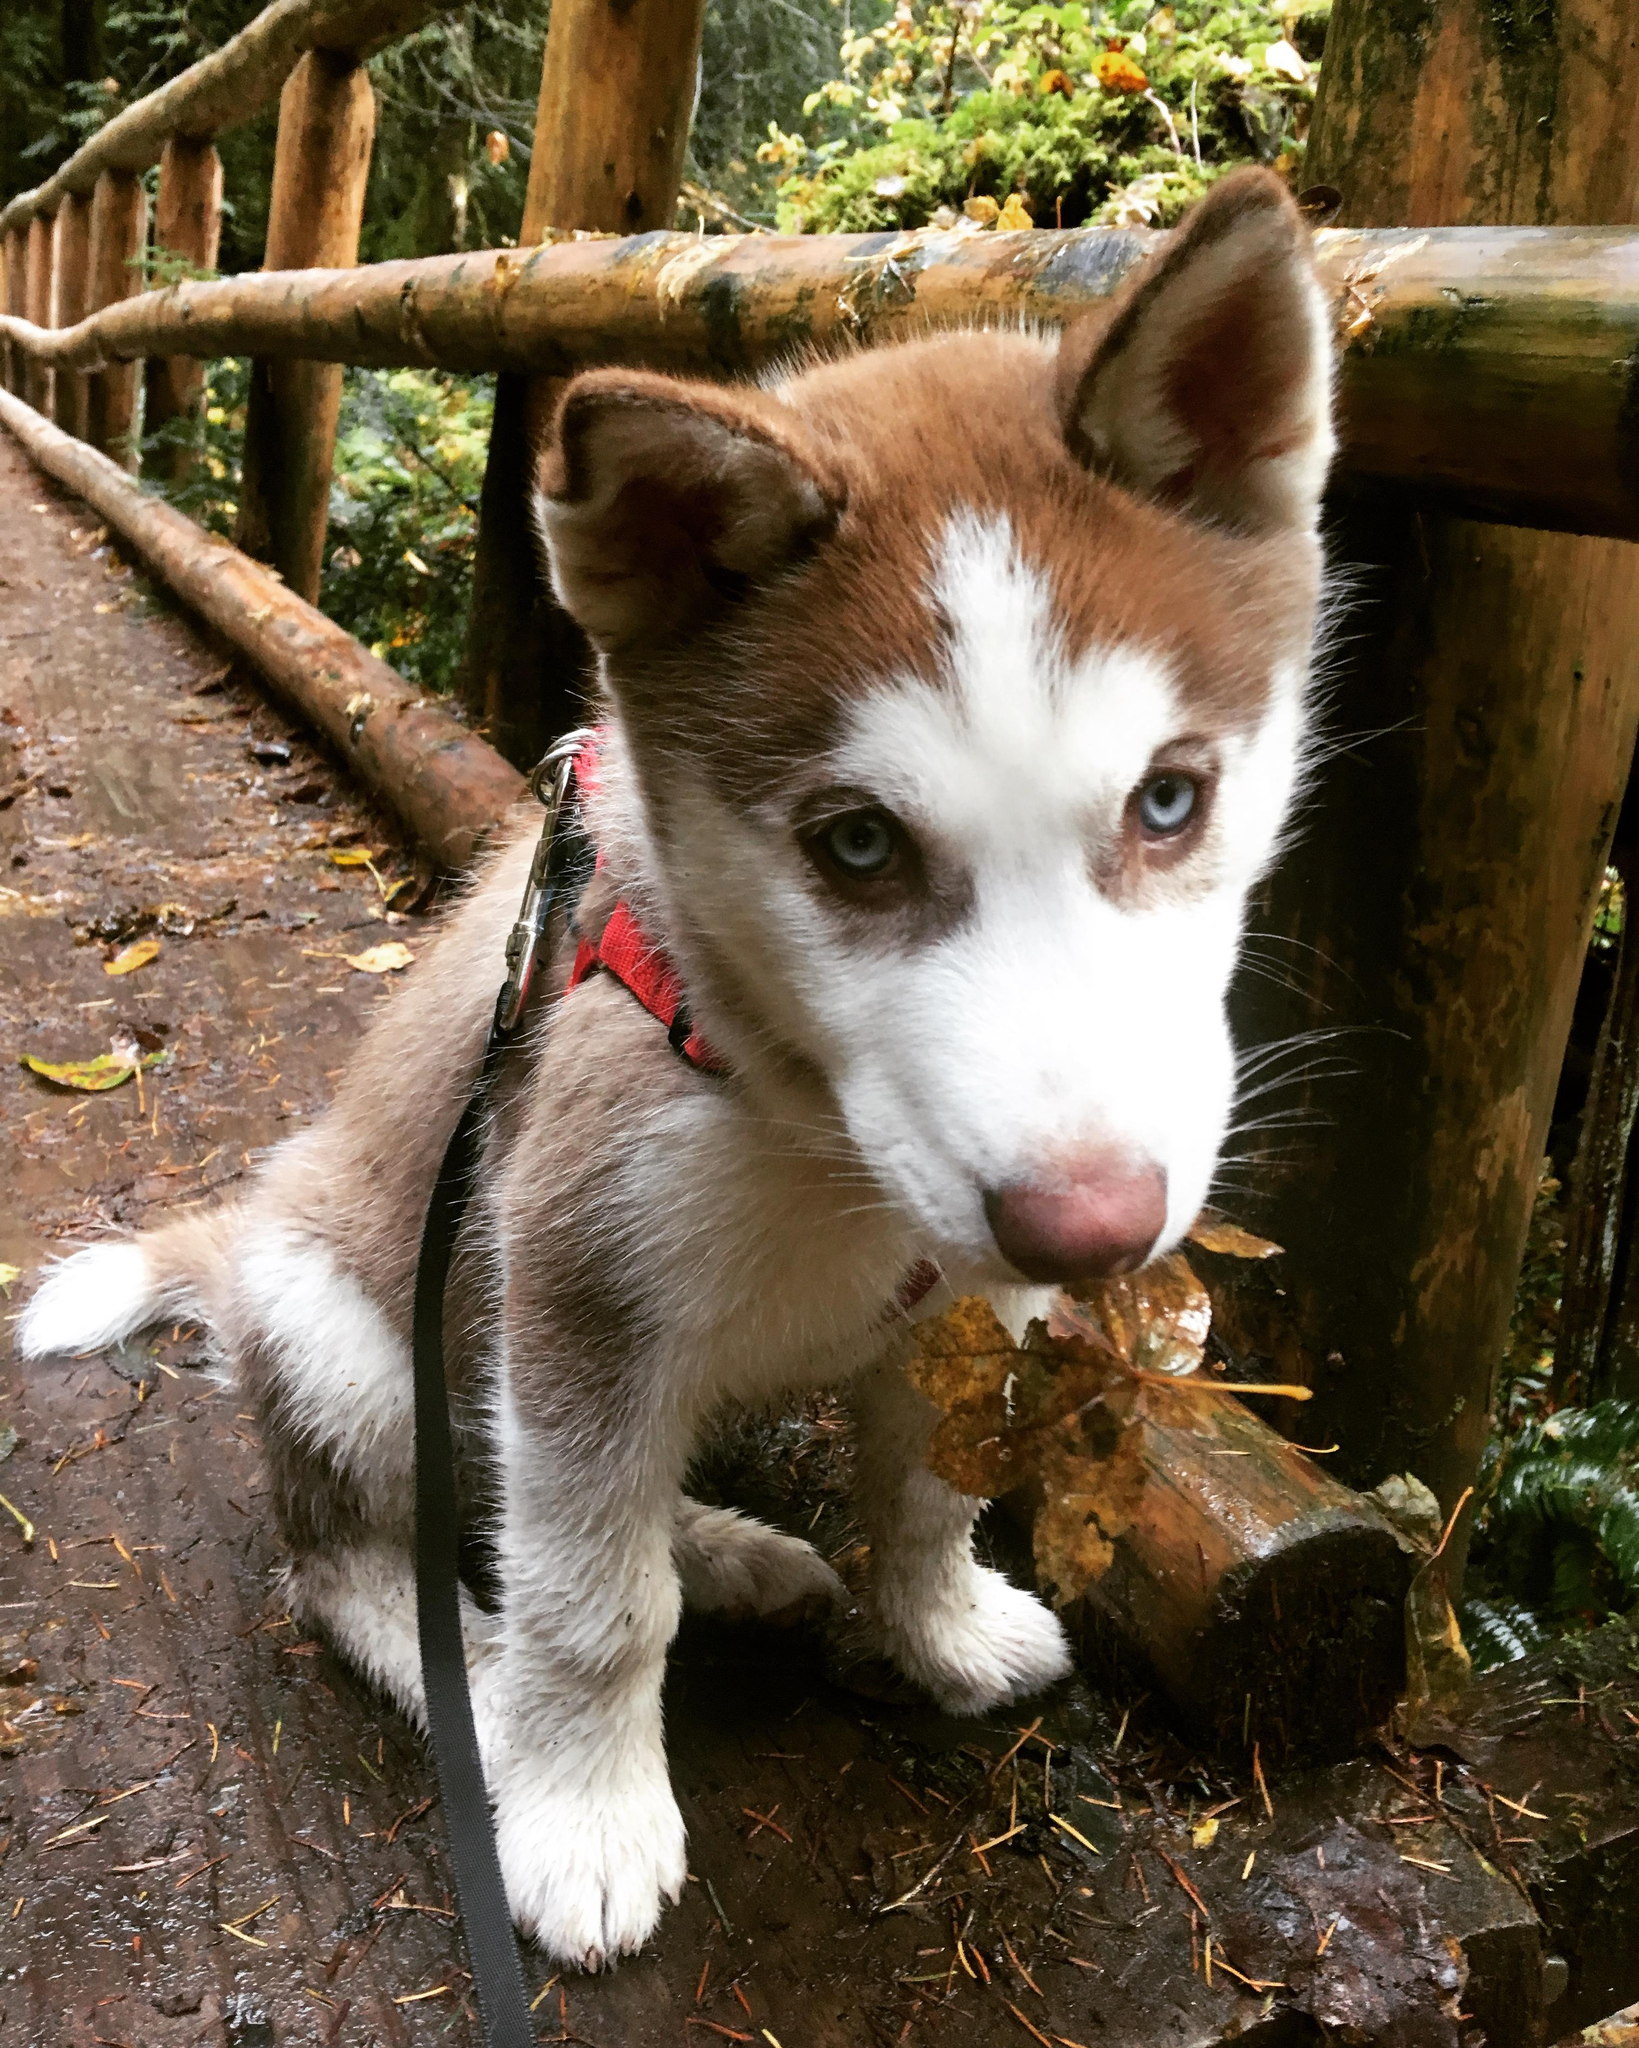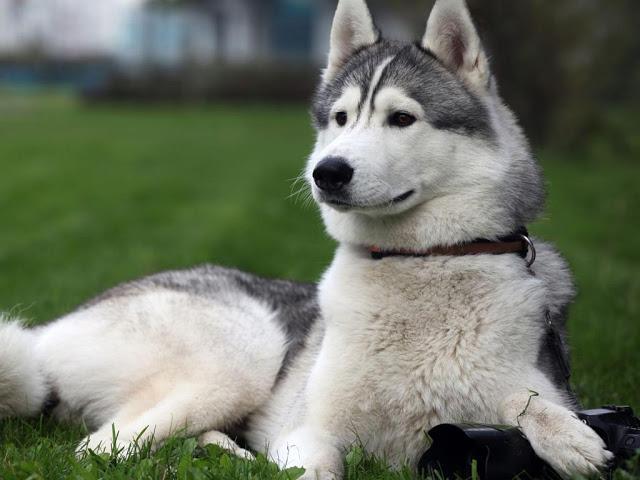The first image is the image on the left, the second image is the image on the right. Given the left and right images, does the statement "The right image shows a non-standing adult husky dog with its head upright, and the left image shows a husky puppy with its head down but its eyes gazing upward." hold true? Answer yes or no. Yes. The first image is the image on the left, the second image is the image on the right. Considering the images on both sides, is "At least one Malamute is sitting in the snow." valid? Answer yes or no. No. 